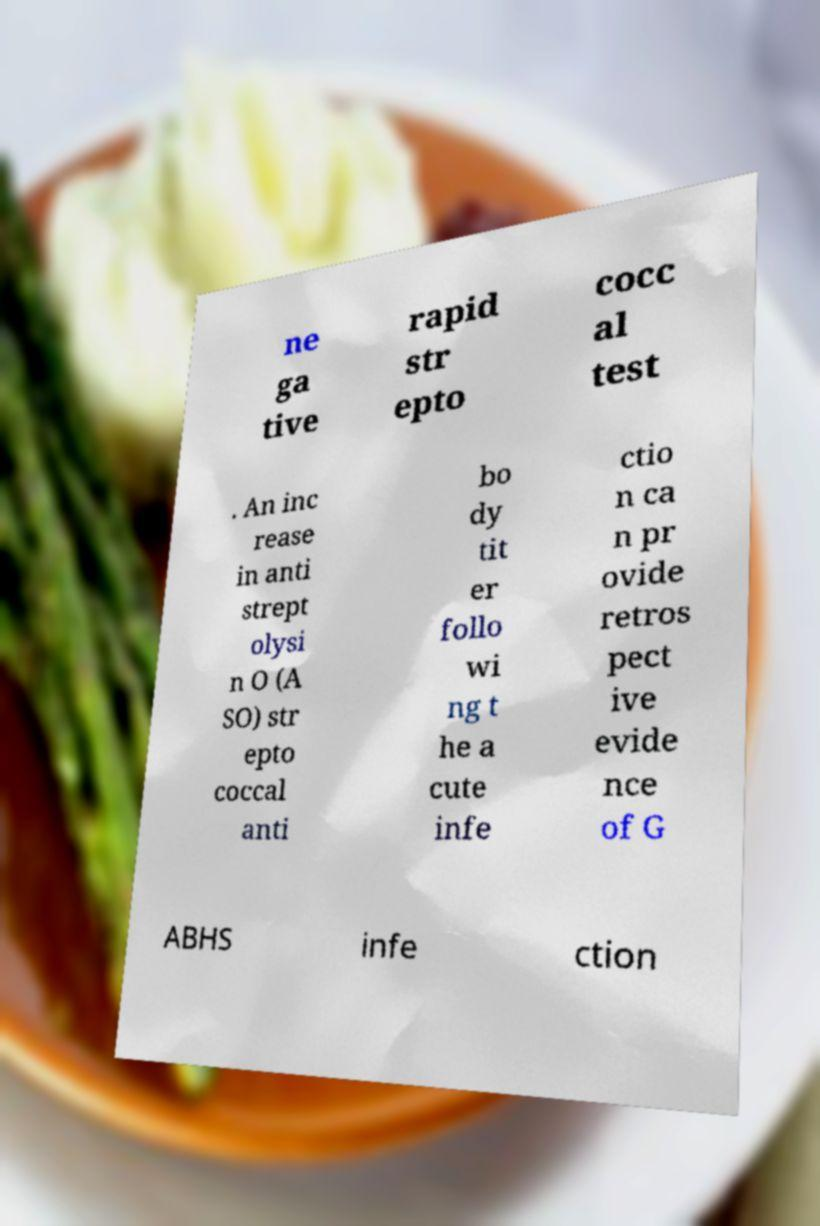Could you extract and type out the text from this image? ne ga tive rapid str epto cocc al test . An inc rease in anti strept olysi n O (A SO) str epto coccal anti bo dy tit er follo wi ng t he a cute infe ctio n ca n pr ovide retros pect ive evide nce of G ABHS infe ction 